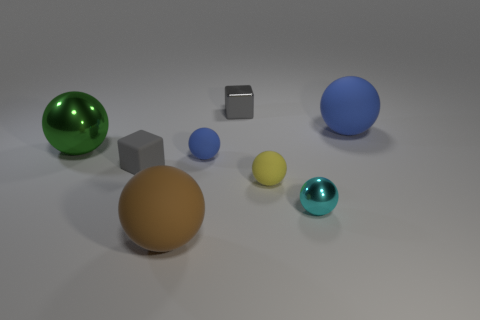What is the size of the green object that is the same shape as the big blue matte object?
Ensure brevity in your answer.  Large. What is the size of the ball that is behind the small blue ball and on the right side of the tiny rubber block?
Offer a terse response. Large. There is a matte thing that is the same color as the metallic cube; what shape is it?
Your answer should be very brief. Cube. What color is the small rubber block?
Your answer should be very brief. Gray. What is the size of the metallic sphere left of the large brown object?
Provide a short and direct response. Large. There is a large thing in front of the shiny ball that is to the right of the yellow matte sphere; how many tiny yellow spheres are on the right side of it?
Provide a succinct answer. 1. There is a metallic ball left of the blue ball in front of the large blue rubber ball; what is its color?
Give a very brief answer. Green. Is there a gray cylinder of the same size as the green thing?
Give a very brief answer. No. There is a gray cube that is in front of the gray object that is behind the large sphere that is on the left side of the brown matte ball; what is its material?
Ensure brevity in your answer.  Rubber. There is a matte object right of the small shiny ball; what number of blue things are to the left of it?
Give a very brief answer. 1. 